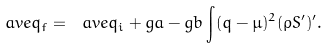<formula> <loc_0><loc_0><loc_500><loc_500>\ a v e { q } _ { f } = \ a v e { q } _ { i } + g a - g b \int ( q - \mu ) ^ { 2 } ( \rho S ^ { \prime } ) ^ { \prime } .</formula> 